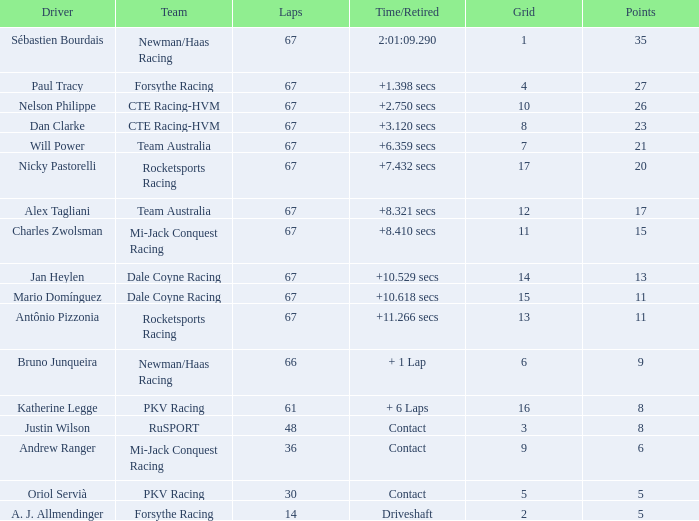What was time/retired with less than 67 laps and 6 points? Contact. 